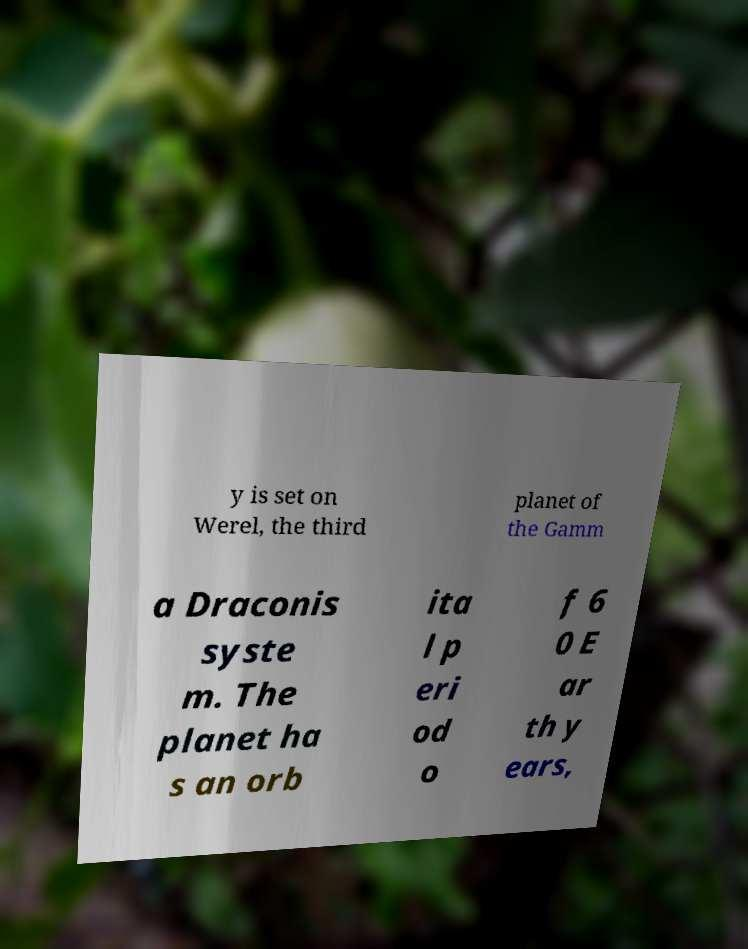Please read and relay the text visible in this image. What does it say? y is set on Werel, the third planet of the Gamm a Draconis syste m. The planet ha s an orb ita l p eri od o f 6 0 E ar th y ears, 